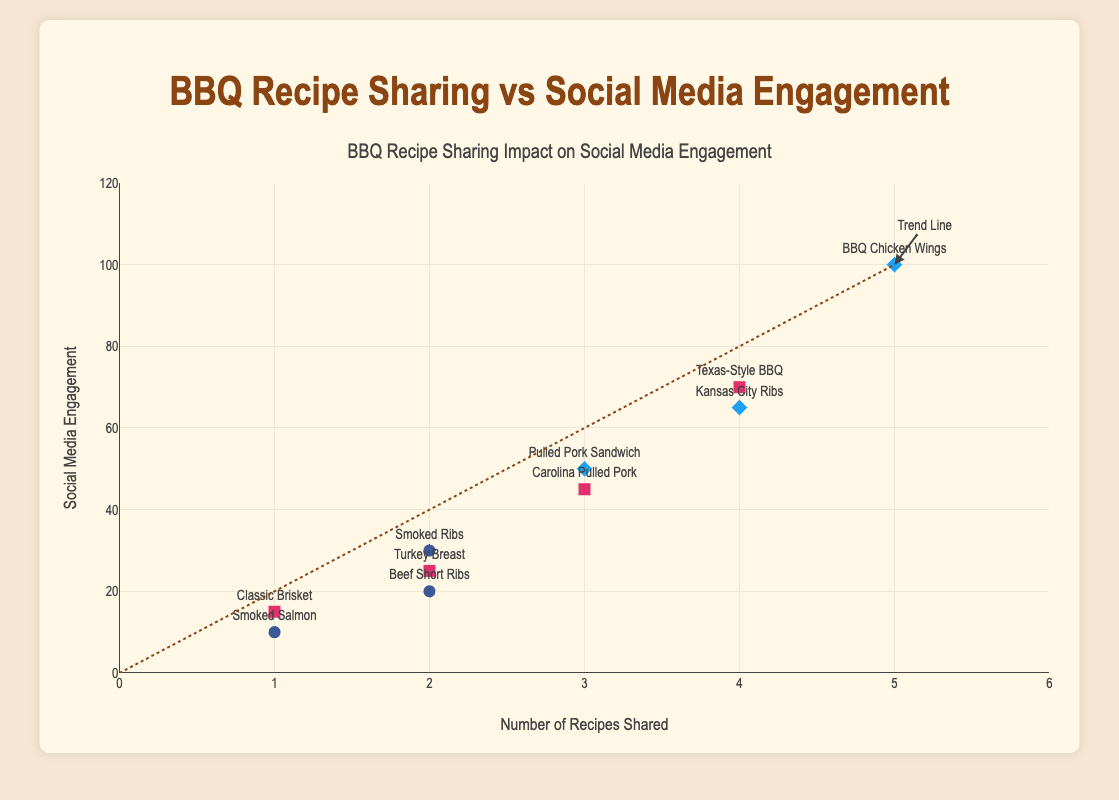What is the title of the figure? The title of the figure is displayed at the top center of the plot and reads "BBQ Recipe Sharing Impact on Social Media Engagement"
Answer: BBQ Recipe Sharing Impact on Social Media Engagement How many recipes are shared on Instagram? From the data points represented with squares, indicating Instagram, there are four recipes shared on this platform: "Classic Brisket," "Texas-Style BBQ," "Turkey Breast," and "Carolina Pulled Pork."
Answer: 4 Which recipe has the highest social media engagement? The recipe with the highest social media engagement is displayed as the highest point on the y-axis, labeled "BBQ Chicken Wings" with an engagement of 100.
Answer: BBQ Chicken Wings What's the average number of social media engagements for recipes shared on Facebook? First, identify Facebook data points (circles) and their engagement values (10, 30, and 20). Sum these values (10 + 30 + 20 = 60) and divide by the number of data points (3): 60 / 3 = 20.
Answer: 20 How does the frequency of recipe sharing influence social media engagement? The trend line illustrates that as the number of recipes shared increases, social media engagement also tends to increase, suggesting a positive correlation.
Answer: Positive correlation Which platform has the most recipes shared? Count the number of recipes for each platform using their respective markers: Instagram (4), Facebook (3), and Twitter (3). Instagram has the most.
Answer: Instagram Which recipe name labels appear near the trend line? The recipes near the trend line include "Carolina Pulled Pork," "Kansas City Ribs," and "BBQ Chicken Wings," indicating these recipes closely follow the trend.
Answer: Carolina Pulled Pork, Kansas City Ribs, BBQ Chicken Wings Which two recipes have the closest social media engagement value but different platforms? "Smoked Ribs" (Facebook, 30) and "Turkey Breast" (Instagram, 25) have the closest engagement values with a difference of 5 on different platforms.
Answer: Smoked Ribs and Turkey Breast What is the engagement value for recipes shared twice? Identify data points with "RecipeShared" equal to 2. The engagement values are 30 (Facebook) and 25, 20 (Instagram), listed as 30, 25, 20.
Answer: 30, 25, 20 